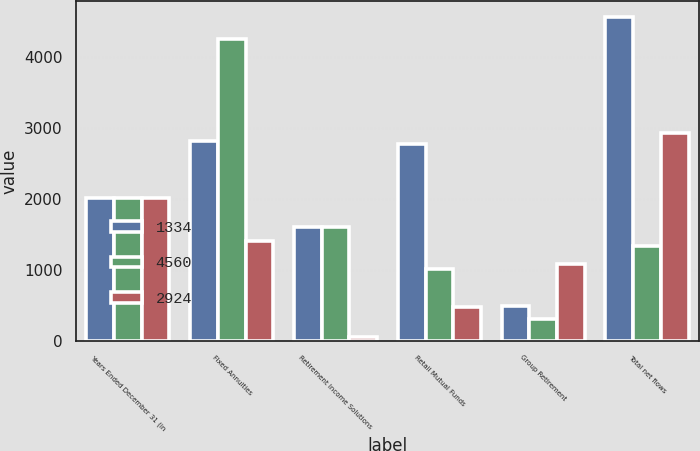<chart> <loc_0><loc_0><loc_500><loc_500><stacked_bar_chart><ecel><fcel>Years Ended December 31 (in<fcel>Fixed Annuities<fcel>Retirement Income Solutions<fcel>Retail Mutual Funds<fcel>Group Retirement<fcel>Total net flows<nl><fcel>1334<fcel>2013<fcel>2820<fcel>1598<fcel>2780<fcel>492<fcel>4560<nl><fcel>4560<fcel>2012<fcel>4252<fcel>1598<fcel>1018<fcel>302<fcel>1334<nl><fcel>2924<fcel>2011<fcel>1406<fcel>48<fcel>478<fcel>1088<fcel>2924<nl></chart> 